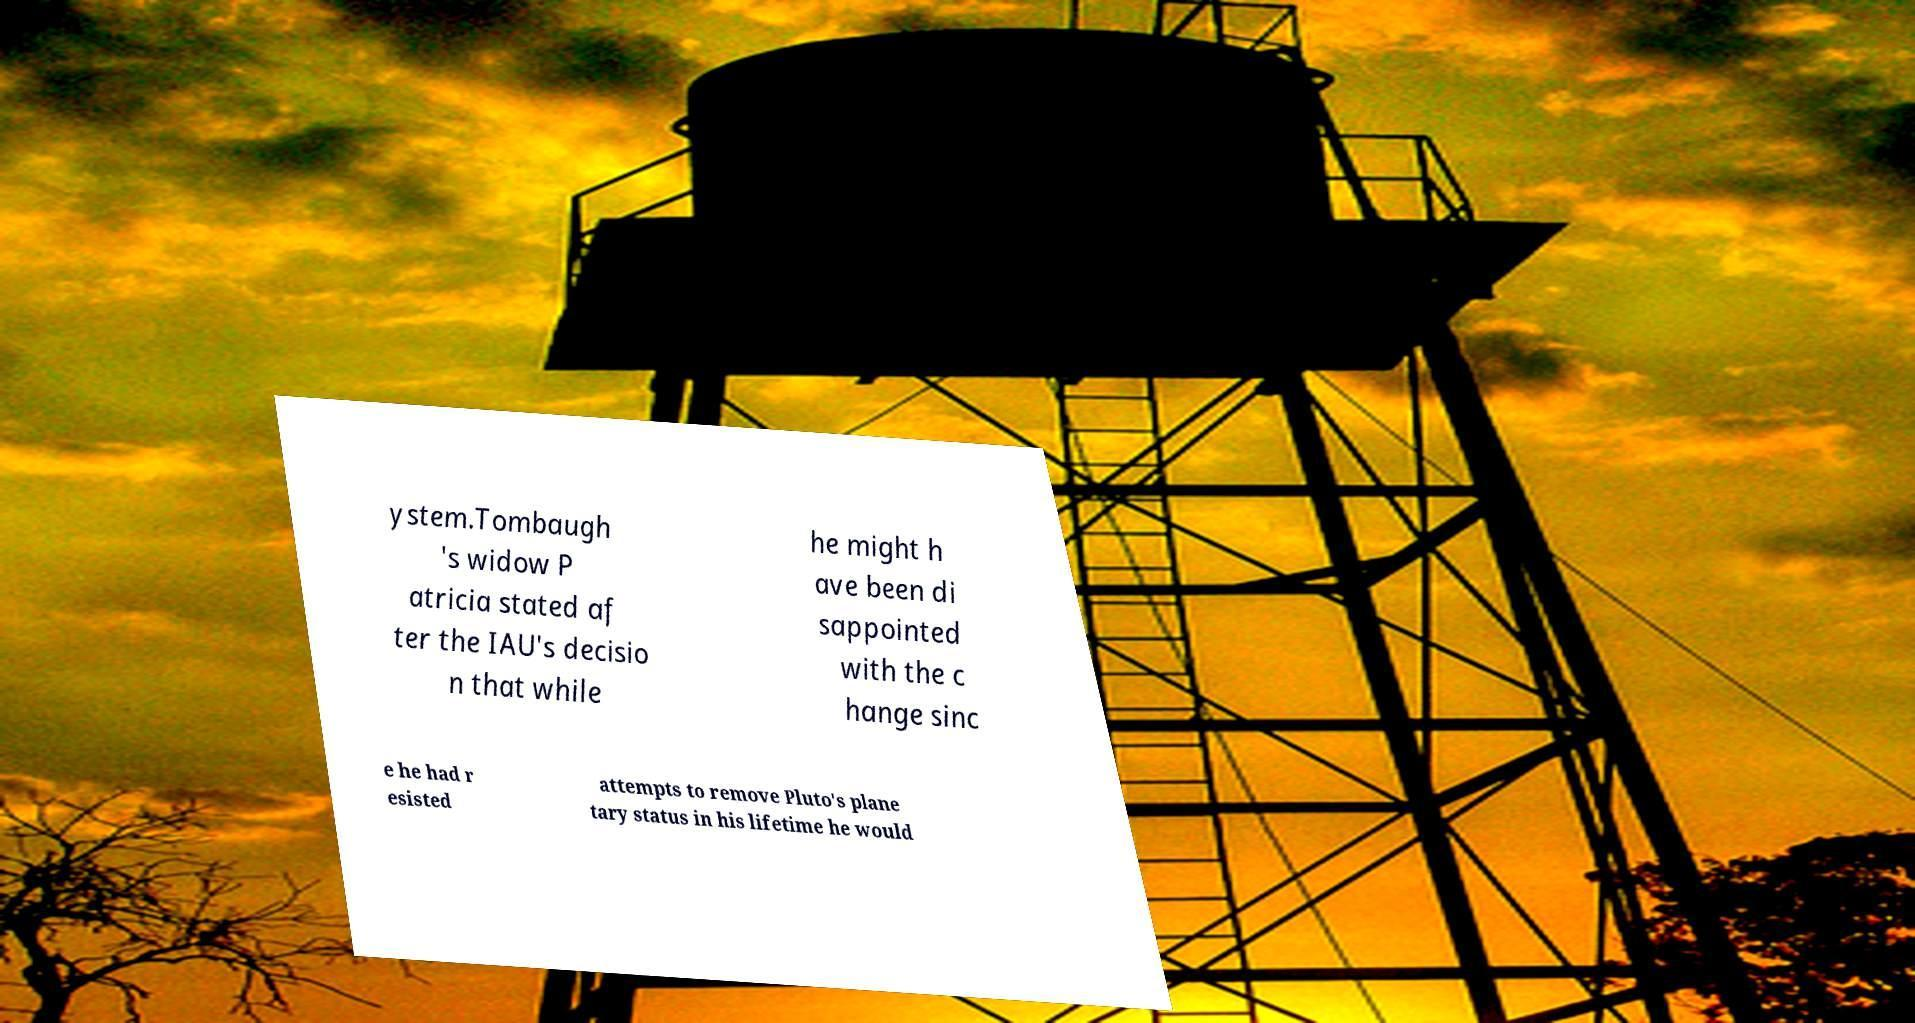Please identify and transcribe the text found in this image. ystem.Tombaugh 's widow P atricia stated af ter the IAU's decisio n that while he might h ave been di sappointed with the c hange sinc e he had r esisted attempts to remove Pluto's plane tary status in his lifetime he would 